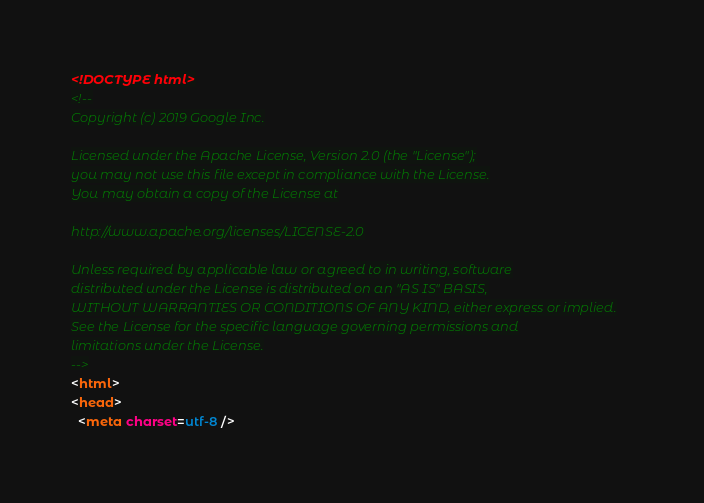<code> <loc_0><loc_0><loc_500><loc_500><_HTML_><!DOCTYPE html>
<!--
Copyright (c) 2019 Google Inc.

Licensed under the Apache License, Version 2.0 (the "License");
you may not use this file except in compliance with the License.
You may obtain a copy of the License at

http://www.apache.org/licenses/LICENSE-2.0

Unless required by applicable law or agreed to in writing, software
distributed under the License is distributed on an "AS IS" BASIS,
WITHOUT WARRANTIES OR CONDITIONS OF ANY KIND, either express or implied.
See the License for the specific language governing permissions and
limitations under the License.
-->
<html>
<head>
  <meta charset=utf-8 /></code> 